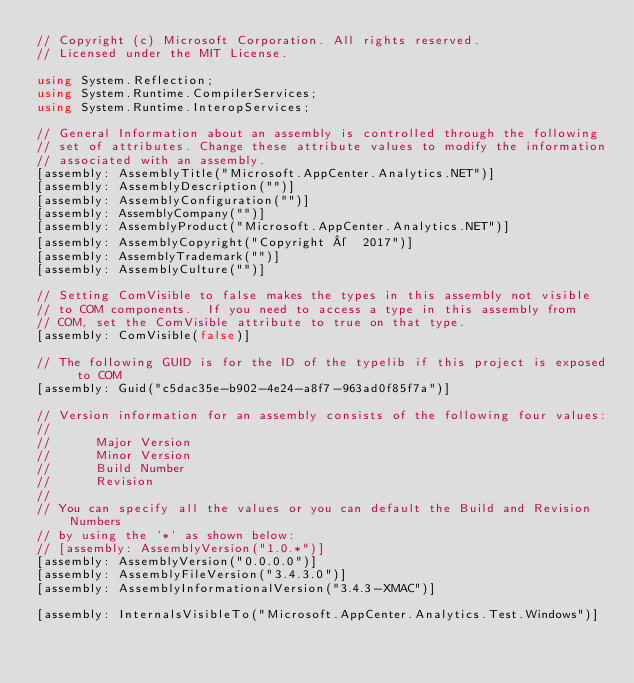Convert code to text. <code><loc_0><loc_0><loc_500><loc_500><_C#_>// Copyright (c) Microsoft Corporation. All rights reserved.
// Licensed under the MIT License.

using System.Reflection;
using System.Runtime.CompilerServices;
using System.Runtime.InteropServices;

// General Information about an assembly is controlled through the following
// set of attributes. Change these attribute values to modify the information
// associated with an assembly.
[assembly: AssemblyTitle("Microsoft.AppCenter.Analytics.NET")]
[assembly: AssemblyDescription("")]
[assembly: AssemblyConfiguration("")]
[assembly: AssemblyCompany("")]
[assembly: AssemblyProduct("Microsoft.AppCenter.Analytics.NET")]
[assembly: AssemblyCopyright("Copyright ©  2017")]
[assembly: AssemblyTrademark("")]
[assembly: AssemblyCulture("")]

// Setting ComVisible to false makes the types in this assembly not visible
// to COM components.  If you need to access a type in this assembly from
// COM, set the ComVisible attribute to true on that type.
[assembly: ComVisible(false)]

// The following GUID is for the ID of the typelib if this project is exposed to COM
[assembly: Guid("c5dac35e-b902-4e24-a8f7-963ad0f85f7a")]

// Version information for an assembly consists of the following four values:
//
//      Major Version
//      Minor Version
//      Build Number
//      Revision
//
// You can specify all the values or you can default the Build and Revision Numbers
// by using the '*' as shown below:
// [assembly: AssemblyVersion("1.0.*")]
[assembly: AssemblyVersion("0.0.0.0")]
[assembly: AssemblyFileVersion("3.4.3.0")]
[assembly: AssemblyInformationalVersion("3.4.3-XMAC")]

[assembly: InternalsVisibleTo("Microsoft.AppCenter.Analytics.Test.Windows")]</code> 